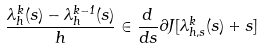<formula> <loc_0><loc_0><loc_500><loc_500>\frac { \lambda ^ { k } _ { h } ( s ) - \lambda ^ { k - 1 } _ { h } ( s ) } { h } \in \frac { d } { d s } \partial J [ \lambda ^ { k } _ { h , s } ( s ) + s ]</formula> 